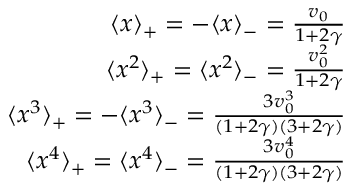<formula> <loc_0><loc_0><loc_500><loc_500>\begin{array} { r l r } & { \langle x \rangle _ { + } = - \langle x \rangle _ { - } = \frac { v _ { 0 } } { 1 + 2 \gamma } } \\ & { \langle x ^ { 2 } \rangle _ { + } = \langle x ^ { 2 } \rangle _ { - } = \frac { v _ { 0 } ^ { 2 } } { 1 + 2 \gamma } } \\ & { \langle x ^ { 3 } \rangle _ { + } = - \langle x ^ { 3 } \rangle _ { - } = \frac { 3 v _ { 0 } ^ { 3 } } { ( 1 + 2 \gamma ) ( 3 + 2 \gamma ) } } \\ & { \langle x ^ { 4 } \rangle _ { + } = \langle x ^ { 4 } \rangle _ { - } = \frac { 3 v _ { 0 } ^ { 4 } } { ( 1 + 2 \gamma ) ( 3 + 2 \gamma ) } } \end{array}</formula> 